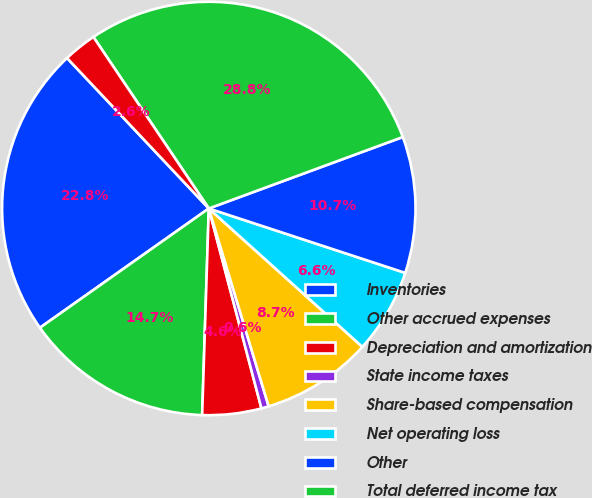Convert chart. <chart><loc_0><loc_0><loc_500><loc_500><pie_chart><fcel>Inventories<fcel>Other accrued expenses<fcel>Depreciation and amortization<fcel>State income taxes<fcel>Share-based compensation<fcel>Net operating loss<fcel>Other<fcel>Total deferred income tax<fcel>Less valuation allowances<nl><fcel>22.76%<fcel>14.7%<fcel>4.61%<fcel>0.58%<fcel>8.65%<fcel>6.63%<fcel>10.66%<fcel>28.81%<fcel>2.6%<nl></chart> 